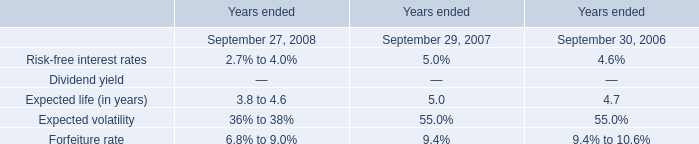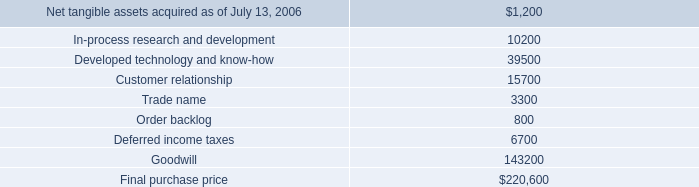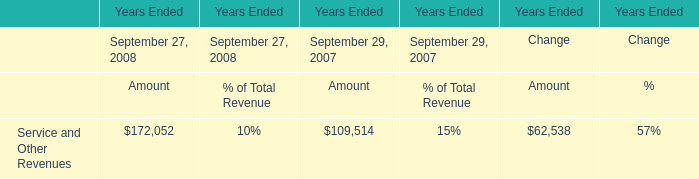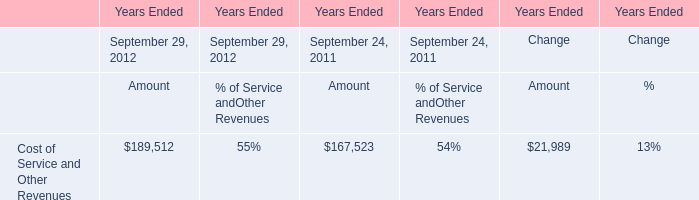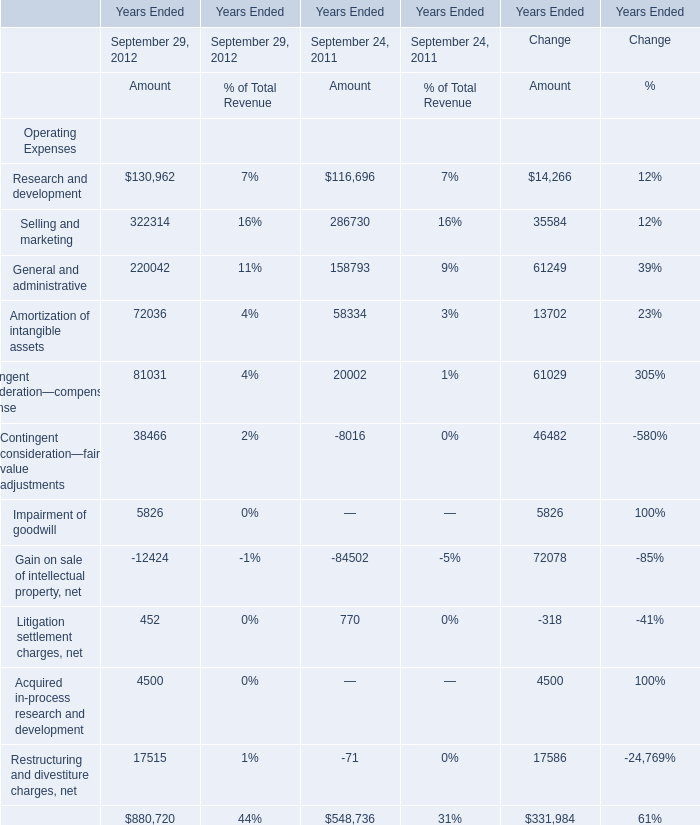What is the sum of the Contingent consideration—fair value adjustments in the years where Amortization of intangible assets is positive? 
Computations: (38466 - 8016)
Answer: 30450.0. 